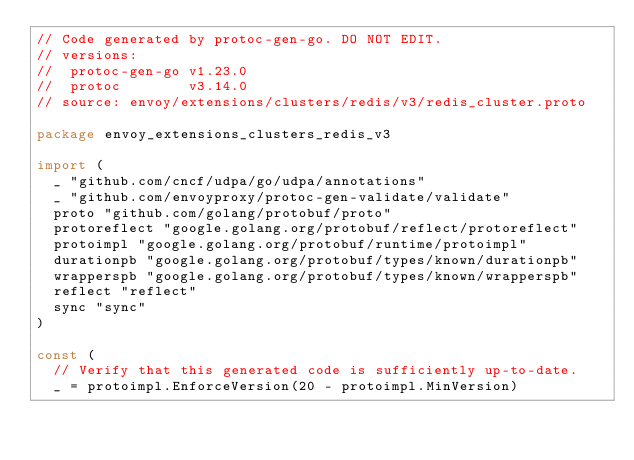<code> <loc_0><loc_0><loc_500><loc_500><_Go_>// Code generated by protoc-gen-go. DO NOT EDIT.
// versions:
// 	protoc-gen-go v1.23.0
// 	protoc        v3.14.0
// source: envoy/extensions/clusters/redis/v3/redis_cluster.proto

package envoy_extensions_clusters_redis_v3

import (
	_ "github.com/cncf/udpa/go/udpa/annotations"
	_ "github.com/envoyproxy/protoc-gen-validate/validate"
	proto "github.com/golang/protobuf/proto"
	protoreflect "google.golang.org/protobuf/reflect/protoreflect"
	protoimpl "google.golang.org/protobuf/runtime/protoimpl"
	durationpb "google.golang.org/protobuf/types/known/durationpb"
	wrapperspb "google.golang.org/protobuf/types/known/wrapperspb"
	reflect "reflect"
	sync "sync"
)

const (
	// Verify that this generated code is sufficiently up-to-date.
	_ = protoimpl.EnforceVersion(20 - protoimpl.MinVersion)</code> 